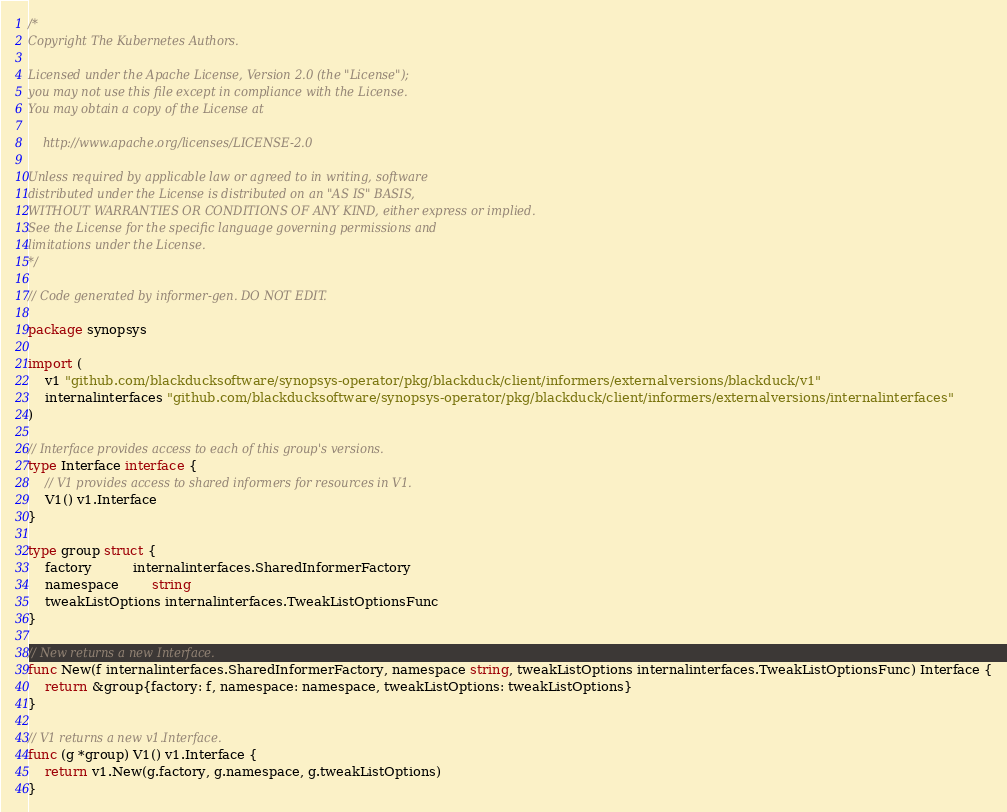<code> <loc_0><loc_0><loc_500><loc_500><_Go_>/*
Copyright The Kubernetes Authors.

Licensed under the Apache License, Version 2.0 (the "License");
you may not use this file except in compliance with the License.
You may obtain a copy of the License at

    http://www.apache.org/licenses/LICENSE-2.0

Unless required by applicable law or agreed to in writing, software
distributed under the License is distributed on an "AS IS" BASIS,
WITHOUT WARRANTIES OR CONDITIONS OF ANY KIND, either express or implied.
See the License for the specific language governing permissions and
limitations under the License.
*/

// Code generated by informer-gen. DO NOT EDIT.

package synopsys

import (
	v1 "github.com/blackducksoftware/synopsys-operator/pkg/blackduck/client/informers/externalversions/blackduck/v1"
	internalinterfaces "github.com/blackducksoftware/synopsys-operator/pkg/blackduck/client/informers/externalversions/internalinterfaces"
)

// Interface provides access to each of this group's versions.
type Interface interface {
	// V1 provides access to shared informers for resources in V1.
	V1() v1.Interface
}

type group struct {
	factory          internalinterfaces.SharedInformerFactory
	namespace        string
	tweakListOptions internalinterfaces.TweakListOptionsFunc
}

// New returns a new Interface.
func New(f internalinterfaces.SharedInformerFactory, namespace string, tweakListOptions internalinterfaces.TweakListOptionsFunc) Interface {
	return &group{factory: f, namespace: namespace, tweakListOptions: tweakListOptions}
}

// V1 returns a new v1.Interface.
func (g *group) V1() v1.Interface {
	return v1.New(g.factory, g.namespace, g.tweakListOptions)
}
</code> 